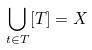Convert formula to latex. <formula><loc_0><loc_0><loc_500><loc_500>\bigcup _ { t \in T } [ T ] = X</formula> 